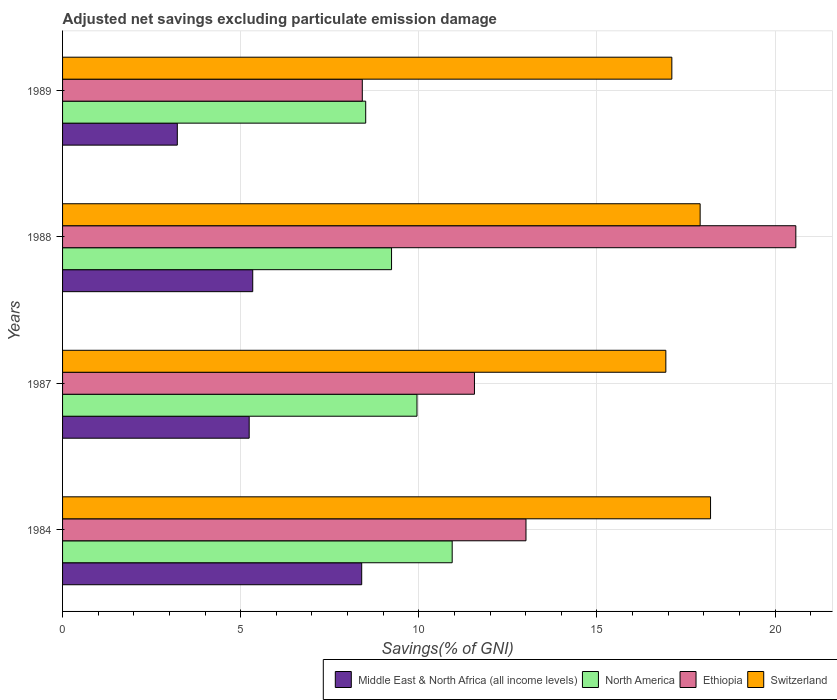How many groups of bars are there?
Your response must be concise. 4. How many bars are there on the 2nd tick from the top?
Your response must be concise. 4. What is the adjusted net savings in Middle East & North Africa (all income levels) in 1984?
Offer a very short reply. 8.4. Across all years, what is the maximum adjusted net savings in North America?
Your answer should be very brief. 10.94. Across all years, what is the minimum adjusted net savings in Switzerland?
Your response must be concise. 16.93. What is the total adjusted net savings in Middle East & North Africa (all income levels) in the graph?
Keep it short and to the point. 22.2. What is the difference between the adjusted net savings in Switzerland in 1984 and that in 1988?
Provide a short and direct response. 0.29. What is the difference between the adjusted net savings in Ethiopia in 1989 and the adjusted net savings in Middle East & North Africa (all income levels) in 1984?
Make the answer very short. 0.02. What is the average adjusted net savings in Middle East & North Africa (all income levels) per year?
Your answer should be very brief. 5.55. In the year 1984, what is the difference between the adjusted net savings in Switzerland and adjusted net savings in North America?
Make the answer very short. 7.25. What is the ratio of the adjusted net savings in Middle East & North Africa (all income levels) in 1984 to that in 1987?
Offer a very short reply. 1.6. What is the difference between the highest and the second highest adjusted net savings in Switzerland?
Ensure brevity in your answer.  0.29. What is the difference between the highest and the lowest adjusted net savings in North America?
Ensure brevity in your answer.  2.43. In how many years, is the adjusted net savings in Ethiopia greater than the average adjusted net savings in Ethiopia taken over all years?
Ensure brevity in your answer.  1. Is it the case that in every year, the sum of the adjusted net savings in Ethiopia and adjusted net savings in Switzerland is greater than the sum of adjusted net savings in Middle East & North Africa (all income levels) and adjusted net savings in North America?
Provide a short and direct response. Yes. What does the 2nd bar from the top in 1984 represents?
Ensure brevity in your answer.  Ethiopia. What does the 4th bar from the bottom in 1989 represents?
Offer a terse response. Switzerland. Is it the case that in every year, the sum of the adjusted net savings in North America and adjusted net savings in Switzerland is greater than the adjusted net savings in Middle East & North Africa (all income levels)?
Make the answer very short. Yes. How many years are there in the graph?
Offer a very short reply. 4. Does the graph contain any zero values?
Offer a very short reply. No. Where does the legend appear in the graph?
Your answer should be very brief. Bottom right. How many legend labels are there?
Your response must be concise. 4. What is the title of the graph?
Your response must be concise. Adjusted net savings excluding particulate emission damage. What is the label or title of the X-axis?
Your response must be concise. Savings(% of GNI). What is the label or title of the Y-axis?
Offer a terse response. Years. What is the Savings(% of GNI) of Middle East & North Africa (all income levels) in 1984?
Ensure brevity in your answer.  8.4. What is the Savings(% of GNI) of North America in 1984?
Provide a short and direct response. 10.94. What is the Savings(% of GNI) in Ethiopia in 1984?
Your answer should be very brief. 13.01. What is the Savings(% of GNI) in Switzerland in 1984?
Your answer should be compact. 18.19. What is the Savings(% of GNI) of Middle East & North Africa (all income levels) in 1987?
Offer a very short reply. 5.24. What is the Savings(% of GNI) of North America in 1987?
Provide a succinct answer. 9.95. What is the Savings(% of GNI) in Ethiopia in 1987?
Offer a very short reply. 11.56. What is the Savings(% of GNI) of Switzerland in 1987?
Your answer should be compact. 16.93. What is the Savings(% of GNI) of Middle East & North Africa (all income levels) in 1988?
Your response must be concise. 5.34. What is the Savings(% of GNI) of North America in 1988?
Make the answer very short. 9.24. What is the Savings(% of GNI) in Ethiopia in 1988?
Provide a short and direct response. 20.58. What is the Savings(% of GNI) in Switzerland in 1988?
Make the answer very short. 17.9. What is the Savings(% of GNI) in Middle East & North Africa (all income levels) in 1989?
Provide a succinct answer. 3.22. What is the Savings(% of GNI) of North America in 1989?
Ensure brevity in your answer.  8.51. What is the Savings(% of GNI) of Ethiopia in 1989?
Offer a very short reply. 8.41. What is the Savings(% of GNI) of Switzerland in 1989?
Your response must be concise. 17.1. Across all years, what is the maximum Savings(% of GNI) in Middle East & North Africa (all income levels)?
Provide a succinct answer. 8.4. Across all years, what is the maximum Savings(% of GNI) in North America?
Your response must be concise. 10.94. Across all years, what is the maximum Savings(% of GNI) in Ethiopia?
Make the answer very short. 20.58. Across all years, what is the maximum Savings(% of GNI) of Switzerland?
Your answer should be compact. 18.19. Across all years, what is the minimum Savings(% of GNI) of Middle East & North Africa (all income levels)?
Your response must be concise. 3.22. Across all years, what is the minimum Savings(% of GNI) of North America?
Keep it short and to the point. 8.51. Across all years, what is the minimum Savings(% of GNI) in Ethiopia?
Give a very brief answer. 8.41. Across all years, what is the minimum Savings(% of GNI) in Switzerland?
Your answer should be very brief. 16.93. What is the total Savings(% of GNI) in Middle East & North Africa (all income levels) in the graph?
Provide a short and direct response. 22.2. What is the total Savings(% of GNI) in North America in the graph?
Keep it short and to the point. 38.63. What is the total Savings(% of GNI) in Ethiopia in the graph?
Provide a succinct answer. 53.57. What is the total Savings(% of GNI) of Switzerland in the graph?
Your answer should be compact. 70.13. What is the difference between the Savings(% of GNI) of Middle East & North Africa (all income levels) in 1984 and that in 1987?
Make the answer very short. 3.16. What is the difference between the Savings(% of GNI) in North America in 1984 and that in 1987?
Your answer should be compact. 0.99. What is the difference between the Savings(% of GNI) in Ethiopia in 1984 and that in 1987?
Your answer should be very brief. 1.45. What is the difference between the Savings(% of GNI) of Switzerland in 1984 and that in 1987?
Ensure brevity in your answer.  1.25. What is the difference between the Savings(% of GNI) of Middle East & North Africa (all income levels) in 1984 and that in 1988?
Offer a very short reply. 3.06. What is the difference between the Savings(% of GNI) of North America in 1984 and that in 1988?
Your answer should be very brief. 1.7. What is the difference between the Savings(% of GNI) in Ethiopia in 1984 and that in 1988?
Offer a very short reply. -7.58. What is the difference between the Savings(% of GNI) of Switzerland in 1984 and that in 1988?
Offer a very short reply. 0.29. What is the difference between the Savings(% of GNI) of Middle East & North Africa (all income levels) in 1984 and that in 1989?
Your answer should be compact. 5.18. What is the difference between the Savings(% of GNI) in North America in 1984 and that in 1989?
Your answer should be very brief. 2.43. What is the difference between the Savings(% of GNI) of Ethiopia in 1984 and that in 1989?
Your answer should be compact. 4.59. What is the difference between the Savings(% of GNI) of Switzerland in 1984 and that in 1989?
Make the answer very short. 1.09. What is the difference between the Savings(% of GNI) of Middle East & North Africa (all income levels) in 1987 and that in 1988?
Make the answer very short. -0.1. What is the difference between the Savings(% of GNI) in North America in 1987 and that in 1988?
Your answer should be very brief. 0.71. What is the difference between the Savings(% of GNI) of Ethiopia in 1987 and that in 1988?
Offer a very short reply. -9.02. What is the difference between the Savings(% of GNI) of Switzerland in 1987 and that in 1988?
Provide a short and direct response. -0.96. What is the difference between the Savings(% of GNI) in Middle East & North Africa (all income levels) in 1987 and that in 1989?
Your answer should be very brief. 2.02. What is the difference between the Savings(% of GNI) in North America in 1987 and that in 1989?
Give a very brief answer. 1.44. What is the difference between the Savings(% of GNI) of Ethiopia in 1987 and that in 1989?
Give a very brief answer. 3.15. What is the difference between the Savings(% of GNI) of Switzerland in 1987 and that in 1989?
Your response must be concise. -0.17. What is the difference between the Savings(% of GNI) of Middle East & North Africa (all income levels) in 1988 and that in 1989?
Ensure brevity in your answer.  2.12. What is the difference between the Savings(% of GNI) in North America in 1988 and that in 1989?
Give a very brief answer. 0.73. What is the difference between the Savings(% of GNI) of Ethiopia in 1988 and that in 1989?
Keep it short and to the point. 12.17. What is the difference between the Savings(% of GNI) in Switzerland in 1988 and that in 1989?
Provide a succinct answer. 0.79. What is the difference between the Savings(% of GNI) in Middle East & North Africa (all income levels) in 1984 and the Savings(% of GNI) in North America in 1987?
Make the answer very short. -1.55. What is the difference between the Savings(% of GNI) in Middle East & North Africa (all income levels) in 1984 and the Savings(% of GNI) in Ethiopia in 1987?
Make the answer very short. -3.17. What is the difference between the Savings(% of GNI) of Middle East & North Africa (all income levels) in 1984 and the Savings(% of GNI) of Switzerland in 1987?
Provide a succinct answer. -8.54. What is the difference between the Savings(% of GNI) in North America in 1984 and the Savings(% of GNI) in Ethiopia in 1987?
Ensure brevity in your answer.  -0.63. What is the difference between the Savings(% of GNI) in North America in 1984 and the Savings(% of GNI) in Switzerland in 1987?
Offer a terse response. -6. What is the difference between the Savings(% of GNI) in Ethiopia in 1984 and the Savings(% of GNI) in Switzerland in 1987?
Provide a succinct answer. -3.93. What is the difference between the Savings(% of GNI) of Middle East & North Africa (all income levels) in 1984 and the Savings(% of GNI) of North America in 1988?
Offer a very short reply. -0.84. What is the difference between the Savings(% of GNI) in Middle East & North Africa (all income levels) in 1984 and the Savings(% of GNI) in Ethiopia in 1988?
Give a very brief answer. -12.19. What is the difference between the Savings(% of GNI) in Middle East & North Africa (all income levels) in 1984 and the Savings(% of GNI) in Switzerland in 1988?
Ensure brevity in your answer.  -9.5. What is the difference between the Savings(% of GNI) of North America in 1984 and the Savings(% of GNI) of Ethiopia in 1988?
Keep it short and to the point. -9.65. What is the difference between the Savings(% of GNI) in North America in 1984 and the Savings(% of GNI) in Switzerland in 1988?
Offer a very short reply. -6.96. What is the difference between the Savings(% of GNI) of Ethiopia in 1984 and the Savings(% of GNI) of Switzerland in 1988?
Your answer should be compact. -4.89. What is the difference between the Savings(% of GNI) in Middle East & North Africa (all income levels) in 1984 and the Savings(% of GNI) in North America in 1989?
Offer a very short reply. -0.11. What is the difference between the Savings(% of GNI) of Middle East & North Africa (all income levels) in 1984 and the Savings(% of GNI) of Ethiopia in 1989?
Your answer should be compact. -0.02. What is the difference between the Savings(% of GNI) of Middle East & North Africa (all income levels) in 1984 and the Savings(% of GNI) of Switzerland in 1989?
Your response must be concise. -8.71. What is the difference between the Savings(% of GNI) in North America in 1984 and the Savings(% of GNI) in Ethiopia in 1989?
Your response must be concise. 2.52. What is the difference between the Savings(% of GNI) in North America in 1984 and the Savings(% of GNI) in Switzerland in 1989?
Your response must be concise. -6.17. What is the difference between the Savings(% of GNI) of Ethiopia in 1984 and the Savings(% of GNI) of Switzerland in 1989?
Ensure brevity in your answer.  -4.09. What is the difference between the Savings(% of GNI) of Middle East & North Africa (all income levels) in 1987 and the Savings(% of GNI) of North America in 1988?
Your answer should be very brief. -4. What is the difference between the Savings(% of GNI) in Middle East & North Africa (all income levels) in 1987 and the Savings(% of GNI) in Ethiopia in 1988?
Give a very brief answer. -15.34. What is the difference between the Savings(% of GNI) of Middle East & North Africa (all income levels) in 1987 and the Savings(% of GNI) of Switzerland in 1988?
Keep it short and to the point. -12.66. What is the difference between the Savings(% of GNI) in North America in 1987 and the Savings(% of GNI) in Ethiopia in 1988?
Offer a terse response. -10.63. What is the difference between the Savings(% of GNI) in North America in 1987 and the Savings(% of GNI) in Switzerland in 1988?
Your answer should be very brief. -7.95. What is the difference between the Savings(% of GNI) in Ethiopia in 1987 and the Savings(% of GNI) in Switzerland in 1988?
Provide a short and direct response. -6.34. What is the difference between the Savings(% of GNI) of Middle East & North Africa (all income levels) in 1987 and the Savings(% of GNI) of North America in 1989?
Offer a terse response. -3.27. What is the difference between the Savings(% of GNI) in Middle East & North Africa (all income levels) in 1987 and the Savings(% of GNI) in Ethiopia in 1989?
Keep it short and to the point. -3.17. What is the difference between the Savings(% of GNI) in Middle East & North Africa (all income levels) in 1987 and the Savings(% of GNI) in Switzerland in 1989?
Make the answer very short. -11.86. What is the difference between the Savings(% of GNI) of North America in 1987 and the Savings(% of GNI) of Ethiopia in 1989?
Give a very brief answer. 1.54. What is the difference between the Savings(% of GNI) of North America in 1987 and the Savings(% of GNI) of Switzerland in 1989?
Your answer should be very brief. -7.15. What is the difference between the Savings(% of GNI) in Ethiopia in 1987 and the Savings(% of GNI) in Switzerland in 1989?
Offer a very short reply. -5.54. What is the difference between the Savings(% of GNI) of Middle East & North Africa (all income levels) in 1988 and the Savings(% of GNI) of North America in 1989?
Provide a short and direct response. -3.17. What is the difference between the Savings(% of GNI) in Middle East & North Africa (all income levels) in 1988 and the Savings(% of GNI) in Ethiopia in 1989?
Give a very brief answer. -3.08. What is the difference between the Savings(% of GNI) of Middle East & North Africa (all income levels) in 1988 and the Savings(% of GNI) of Switzerland in 1989?
Your answer should be very brief. -11.77. What is the difference between the Savings(% of GNI) of North America in 1988 and the Savings(% of GNI) of Ethiopia in 1989?
Your answer should be compact. 0.82. What is the difference between the Savings(% of GNI) of North America in 1988 and the Savings(% of GNI) of Switzerland in 1989?
Offer a very short reply. -7.87. What is the difference between the Savings(% of GNI) of Ethiopia in 1988 and the Savings(% of GNI) of Switzerland in 1989?
Give a very brief answer. 3.48. What is the average Savings(% of GNI) of Middle East & North Africa (all income levels) per year?
Offer a very short reply. 5.55. What is the average Savings(% of GNI) of North America per year?
Ensure brevity in your answer.  9.66. What is the average Savings(% of GNI) of Ethiopia per year?
Make the answer very short. 13.39. What is the average Savings(% of GNI) of Switzerland per year?
Offer a very short reply. 17.53. In the year 1984, what is the difference between the Savings(% of GNI) in Middle East & North Africa (all income levels) and Savings(% of GNI) in North America?
Give a very brief answer. -2.54. In the year 1984, what is the difference between the Savings(% of GNI) in Middle East & North Africa (all income levels) and Savings(% of GNI) in Ethiopia?
Ensure brevity in your answer.  -4.61. In the year 1984, what is the difference between the Savings(% of GNI) in Middle East & North Africa (all income levels) and Savings(% of GNI) in Switzerland?
Your answer should be compact. -9.79. In the year 1984, what is the difference between the Savings(% of GNI) in North America and Savings(% of GNI) in Ethiopia?
Make the answer very short. -2.07. In the year 1984, what is the difference between the Savings(% of GNI) in North America and Savings(% of GNI) in Switzerland?
Provide a succinct answer. -7.25. In the year 1984, what is the difference between the Savings(% of GNI) of Ethiopia and Savings(% of GNI) of Switzerland?
Give a very brief answer. -5.18. In the year 1987, what is the difference between the Savings(% of GNI) of Middle East & North Africa (all income levels) and Savings(% of GNI) of North America?
Keep it short and to the point. -4.71. In the year 1987, what is the difference between the Savings(% of GNI) in Middle East & North Africa (all income levels) and Savings(% of GNI) in Ethiopia?
Provide a short and direct response. -6.32. In the year 1987, what is the difference between the Savings(% of GNI) in Middle East & North Africa (all income levels) and Savings(% of GNI) in Switzerland?
Your answer should be compact. -11.7. In the year 1987, what is the difference between the Savings(% of GNI) in North America and Savings(% of GNI) in Ethiopia?
Offer a terse response. -1.61. In the year 1987, what is the difference between the Savings(% of GNI) of North America and Savings(% of GNI) of Switzerland?
Make the answer very short. -6.99. In the year 1987, what is the difference between the Savings(% of GNI) in Ethiopia and Savings(% of GNI) in Switzerland?
Your answer should be very brief. -5.37. In the year 1988, what is the difference between the Savings(% of GNI) of Middle East & North Africa (all income levels) and Savings(% of GNI) of North America?
Make the answer very short. -3.9. In the year 1988, what is the difference between the Savings(% of GNI) in Middle East & North Africa (all income levels) and Savings(% of GNI) in Ethiopia?
Keep it short and to the point. -15.25. In the year 1988, what is the difference between the Savings(% of GNI) in Middle East & North Africa (all income levels) and Savings(% of GNI) in Switzerland?
Your response must be concise. -12.56. In the year 1988, what is the difference between the Savings(% of GNI) of North America and Savings(% of GNI) of Ethiopia?
Keep it short and to the point. -11.35. In the year 1988, what is the difference between the Savings(% of GNI) in North America and Savings(% of GNI) in Switzerland?
Give a very brief answer. -8.66. In the year 1988, what is the difference between the Savings(% of GNI) of Ethiopia and Savings(% of GNI) of Switzerland?
Provide a succinct answer. 2.69. In the year 1989, what is the difference between the Savings(% of GNI) of Middle East & North Africa (all income levels) and Savings(% of GNI) of North America?
Give a very brief answer. -5.29. In the year 1989, what is the difference between the Savings(% of GNI) in Middle East & North Africa (all income levels) and Savings(% of GNI) in Ethiopia?
Your answer should be very brief. -5.19. In the year 1989, what is the difference between the Savings(% of GNI) in Middle East & North Africa (all income levels) and Savings(% of GNI) in Switzerland?
Your answer should be compact. -13.88. In the year 1989, what is the difference between the Savings(% of GNI) in North America and Savings(% of GNI) in Ethiopia?
Offer a very short reply. 0.1. In the year 1989, what is the difference between the Savings(% of GNI) of North America and Savings(% of GNI) of Switzerland?
Your answer should be very brief. -8.59. In the year 1989, what is the difference between the Savings(% of GNI) in Ethiopia and Savings(% of GNI) in Switzerland?
Your answer should be compact. -8.69. What is the ratio of the Savings(% of GNI) of Middle East & North Africa (all income levels) in 1984 to that in 1987?
Offer a terse response. 1.6. What is the ratio of the Savings(% of GNI) of North America in 1984 to that in 1987?
Provide a succinct answer. 1.1. What is the ratio of the Savings(% of GNI) of Ethiopia in 1984 to that in 1987?
Offer a terse response. 1.13. What is the ratio of the Savings(% of GNI) in Switzerland in 1984 to that in 1987?
Give a very brief answer. 1.07. What is the ratio of the Savings(% of GNI) of Middle East & North Africa (all income levels) in 1984 to that in 1988?
Offer a very short reply. 1.57. What is the ratio of the Savings(% of GNI) of North America in 1984 to that in 1988?
Make the answer very short. 1.18. What is the ratio of the Savings(% of GNI) in Ethiopia in 1984 to that in 1988?
Give a very brief answer. 0.63. What is the ratio of the Savings(% of GNI) in Switzerland in 1984 to that in 1988?
Your answer should be compact. 1.02. What is the ratio of the Savings(% of GNI) of Middle East & North Africa (all income levels) in 1984 to that in 1989?
Your response must be concise. 2.61. What is the ratio of the Savings(% of GNI) of North America in 1984 to that in 1989?
Your answer should be compact. 1.29. What is the ratio of the Savings(% of GNI) in Ethiopia in 1984 to that in 1989?
Your answer should be very brief. 1.55. What is the ratio of the Savings(% of GNI) in Switzerland in 1984 to that in 1989?
Your response must be concise. 1.06. What is the ratio of the Savings(% of GNI) in Middle East & North Africa (all income levels) in 1987 to that in 1988?
Offer a very short reply. 0.98. What is the ratio of the Savings(% of GNI) in North America in 1987 to that in 1988?
Make the answer very short. 1.08. What is the ratio of the Savings(% of GNI) of Ethiopia in 1987 to that in 1988?
Your answer should be compact. 0.56. What is the ratio of the Savings(% of GNI) in Switzerland in 1987 to that in 1988?
Your answer should be compact. 0.95. What is the ratio of the Savings(% of GNI) in Middle East & North Africa (all income levels) in 1987 to that in 1989?
Keep it short and to the point. 1.63. What is the ratio of the Savings(% of GNI) of North America in 1987 to that in 1989?
Keep it short and to the point. 1.17. What is the ratio of the Savings(% of GNI) in Ethiopia in 1987 to that in 1989?
Provide a succinct answer. 1.37. What is the ratio of the Savings(% of GNI) in Switzerland in 1987 to that in 1989?
Offer a terse response. 0.99. What is the ratio of the Savings(% of GNI) of Middle East & North Africa (all income levels) in 1988 to that in 1989?
Offer a terse response. 1.66. What is the ratio of the Savings(% of GNI) of North America in 1988 to that in 1989?
Ensure brevity in your answer.  1.09. What is the ratio of the Savings(% of GNI) in Ethiopia in 1988 to that in 1989?
Provide a succinct answer. 2.45. What is the ratio of the Savings(% of GNI) of Switzerland in 1988 to that in 1989?
Offer a very short reply. 1.05. What is the difference between the highest and the second highest Savings(% of GNI) of Middle East & North Africa (all income levels)?
Your answer should be compact. 3.06. What is the difference between the highest and the second highest Savings(% of GNI) of Ethiopia?
Ensure brevity in your answer.  7.58. What is the difference between the highest and the second highest Savings(% of GNI) in Switzerland?
Your answer should be very brief. 0.29. What is the difference between the highest and the lowest Savings(% of GNI) of Middle East & North Africa (all income levels)?
Make the answer very short. 5.18. What is the difference between the highest and the lowest Savings(% of GNI) in North America?
Your answer should be very brief. 2.43. What is the difference between the highest and the lowest Savings(% of GNI) of Ethiopia?
Provide a short and direct response. 12.17. What is the difference between the highest and the lowest Savings(% of GNI) of Switzerland?
Give a very brief answer. 1.25. 